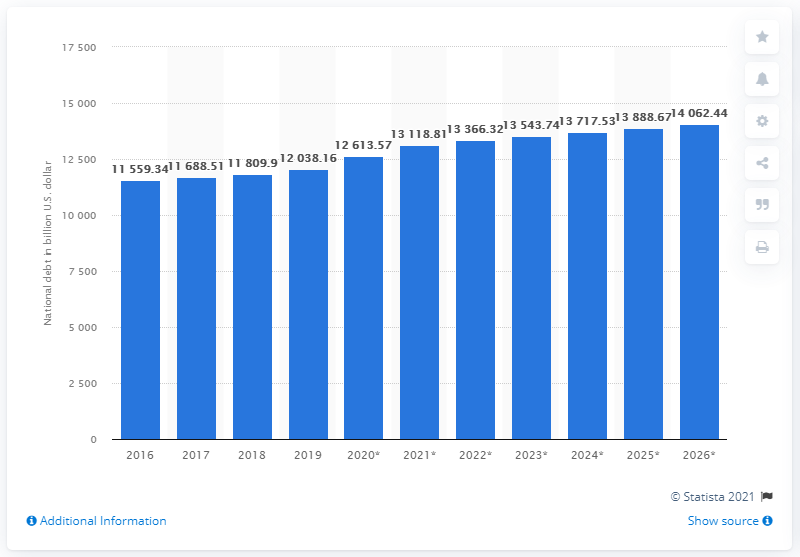List a handful of essential elements in this visual. In 2019, Japan's national debt was approximately 120,381.60 trillion Japanese yen. 